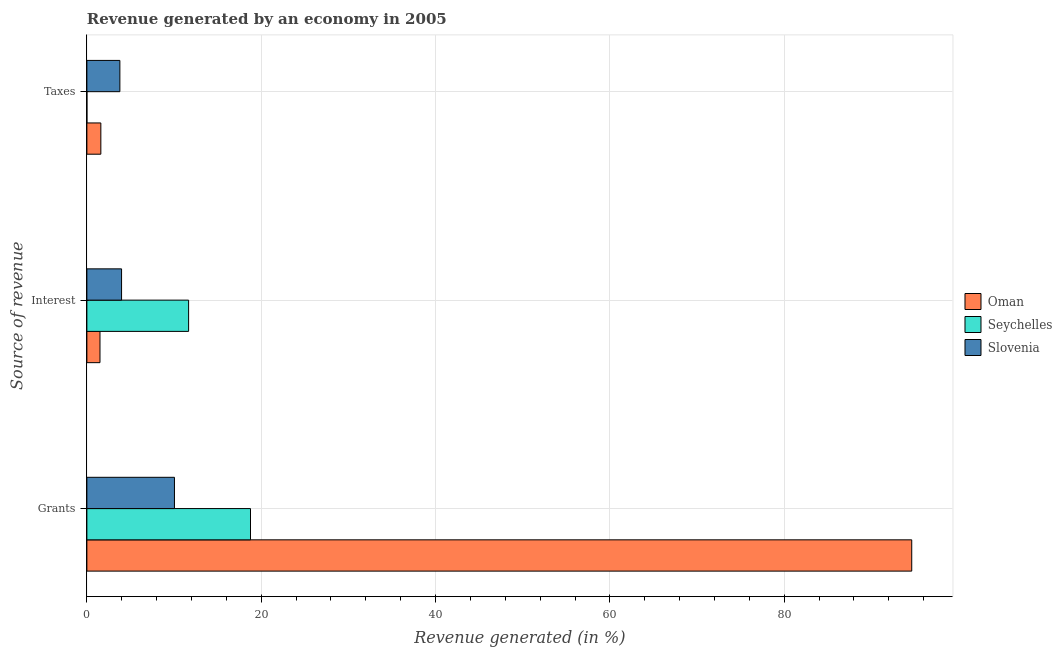How many bars are there on the 1st tick from the top?
Provide a succinct answer. 3. How many bars are there on the 2nd tick from the bottom?
Your response must be concise. 3. What is the label of the 1st group of bars from the top?
Offer a terse response. Taxes. What is the percentage of revenue generated by grants in Slovenia?
Your answer should be compact. 10.05. Across all countries, what is the maximum percentage of revenue generated by interest?
Your response must be concise. 11.67. Across all countries, what is the minimum percentage of revenue generated by taxes?
Provide a short and direct response. 0. In which country was the percentage of revenue generated by taxes maximum?
Your answer should be compact. Slovenia. In which country was the percentage of revenue generated by taxes minimum?
Provide a succinct answer. Seychelles. What is the total percentage of revenue generated by grants in the graph?
Provide a short and direct response. 123.44. What is the difference between the percentage of revenue generated by taxes in Slovenia and that in Oman?
Make the answer very short. 2.18. What is the difference between the percentage of revenue generated by taxes in Oman and the percentage of revenue generated by grants in Slovenia?
Offer a very short reply. -8.44. What is the average percentage of revenue generated by grants per country?
Offer a terse response. 41.15. What is the difference between the percentage of revenue generated by grants and percentage of revenue generated by taxes in Oman?
Give a very brief answer. 93.03. What is the ratio of the percentage of revenue generated by interest in Seychelles to that in Slovenia?
Make the answer very short. 2.93. Is the percentage of revenue generated by grants in Oman less than that in Slovenia?
Provide a short and direct response. No. What is the difference between the highest and the second highest percentage of revenue generated by taxes?
Your answer should be compact. 2.18. What is the difference between the highest and the lowest percentage of revenue generated by interest?
Keep it short and to the point. 10.17. Is the sum of the percentage of revenue generated by grants in Slovenia and Seychelles greater than the maximum percentage of revenue generated by interest across all countries?
Make the answer very short. Yes. What does the 3rd bar from the top in Interest represents?
Provide a short and direct response. Oman. What does the 3rd bar from the bottom in Grants represents?
Provide a succinct answer. Slovenia. Are all the bars in the graph horizontal?
Provide a short and direct response. Yes. How many countries are there in the graph?
Give a very brief answer. 3. What is the difference between two consecutive major ticks on the X-axis?
Your answer should be very brief. 20. Does the graph contain grids?
Make the answer very short. Yes. How are the legend labels stacked?
Your answer should be very brief. Vertical. What is the title of the graph?
Your response must be concise. Revenue generated by an economy in 2005. Does "Japan" appear as one of the legend labels in the graph?
Provide a succinct answer. No. What is the label or title of the X-axis?
Your answer should be very brief. Revenue generated (in %). What is the label or title of the Y-axis?
Your response must be concise. Source of revenue. What is the Revenue generated (in %) in Oman in Grants?
Make the answer very short. 94.63. What is the Revenue generated (in %) in Seychelles in Grants?
Offer a very short reply. 18.77. What is the Revenue generated (in %) of Slovenia in Grants?
Ensure brevity in your answer.  10.05. What is the Revenue generated (in %) in Oman in Interest?
Provide a succinct answer. 1.5. What is the Revenue generated (in %) of Seychelles in Interest?
Your response must be concise. 11.67. What is the Revenue generated (in %) in Slovenia in Interest?
Keep it short and to the point. 3.98. What is the Revenue generated (in %) in Oman in Taxes?
Provide a succinct answer. 1.6. What is the Revenue generated (in %) in Seychelles in Taxes?
Ensure brevity in your answer.  0. What is the Revenue generated (in %) of Slovenia in Taxes?
Provide a short and direct response. 3.79. Across all Source of revenue, what is the maximum Revenue generated (in %) of Oman?
Offer a very short reply. 94.63. Across all Source of revenue, what is the maximum Revenue generated (in %) of Seychelles?
Offer a terse response. 18.77. Across all Source of revenue, what is the maximum Revenue generated (in %) of Slovenia?
Offer a terse response. 10.05. Across all Source of revenue, what is the minimum Revenue generated (in %) of Oman?
Offer a very short reply. 1.5. Across all Source of revenue, what is the minimum Revenue generated (in %) of Seychelles?
Provide a short and direct response. 0. Across all Source of revenue, what is the minimum Revenue generated (in %) of Slovenia?
Make the answer very short. 3.79. What is the total Revenue generated (in %) of Oman in the graph?
Keep it short and to the point. 97.73. What is the total Revenue generated (in %) of Seychelles in the graph?
Provide a succinct answer. 30.44. What is the total Revenue generated (in %) in Slovenia in the graph?
Your answer should be compact. 17.81. What is the difference between the Revenue generated (in %) of Oman in Grants and that in Interest?
Your answer should be very brief. 93.13. What is the difference between the Revenue generated (in %) in Seychelles in Grants and that in Interest?
Your answer should be compact. 7.1. What is the difference between the Revenue generated (in %) in Slovenia in Grants and that in Interest?
Give a very brief answer. 6.07. What is the difference between the Revenue generated (in %) in Oman in Grants and that in Taxes?
Give a very brief answer. 93.03. What is the difference between the Revenue generated (in %) in Seychelles in Grants and that in Taxes?
Provide a short and direct response. 18.77. What is the difference between the Revenue generated (in %) in Slovenia in Grants and that in Taxes?
Your response must be concise. 6.26. What is the difference between the Revenue generated (in %) of Oman in Interest and that in Taxes?
Provide a succinct answer. -0.1. What is the difference between the Revenue generated (in %) of Seychelles in Interest and that in Taxes?
Your answer should be very brief. 11.67. What is the difference between the Revenue generated (in %) in Slovenia in Interest and that in Taxes?
Your answer should be very brief. 0.19. What is the difference between the Revenue generated (in %) in Oman in Grants and the Revenue generated (in %) in Seychelles in Interest?
Make the answer very short. 82.96. What is the difference between the Revenue generated (in %) in Oman in Grants and the Revenue generated (in %) in Slovenia in Interest?
Offer a terse response. 90.65. What is the difference between the Revenue generated (in %) of Seychelles in Grants and the Revenue generated (in %) of Slovenia in Interest?
Ensure brevity in your answer.  14.79. What is the difference between the Revenue generated (in %) of Oman in Grants and the Revenue generated (in %) of Seychelles in Taxes?
Provide a short and direct response. 94.63. What is the difference between the Revenue generated (in %) in Oman in Grants and the Revenue generated (in %) in Slovenia in Taxes?
Provide a succinct answer. 90.84. What is the difference between the Revenue generated (in %) in Seychelles in Grants and the Revenue generated (in %) in Slovenia in Taxes?
Provide a short and direct response. 14.98. What is the difference between the Revenue generated (in %) in Oman in Interest and the Revenue generated (in %) in Seychelles in Taxes?
Offer a very short reply. 1.5. What is the difference between the Revenue generated (in %) of Oman in Interest and the Revenue generated (in %) of Slovenia in Taxes?
Give a very brief answer. -2.28. What is the difference between the Revenue generated (in %) of Seychelles in Interest and the Revenue generated (in %) of Slovenia in Taxes?
Make the answer very short. 7.88. What is the average Revenue generated (in %) in Oman per Source of revenue?
Give a very brief answer. 32.58. What is the average Revenue generated (in %) in Seychelles per Source of revenue?
Your response must be concise. 10.15. What is the average Revenue generated (in %) of Slovenia per Source of revenue?
Provide a succinct answer. 5.94. What is the difference between the Revenue generated (in %) of Oman and Revenue generated (in %) of Seychelles in Grants?
Make the answer very short. 75.86. What is the difference between the Revenue generated (in %) in Oman and Revenue generated (in %) in Slovenia in Grants?
Keep it short and to the point. 84.58. What is the difference between the Revenue generated (in %) of Seychelles and Revenue generated (in %) of Slovenia in Grants?
Your response must be concise. 8.72. What is the difference between the Revenue generated (in %) of Oman and Revenue generated (in %) of Seychelles in Interest?
Offer a very short reply. -10.17. What is the difference between the Revenue generated (in %) in Oman and Revenue generated (in %) in Slovenia in Interest?
Your answer should be compact. -2.48. What is the difference between the Revenue generated (in %) of Seychelles and Revenue generated (in %) of Slovenia in Interest?
Ensure brevity in your answer.  7.69. What is the difference between the Revenue generated (in %) of Oman and Revenue generated (in %) of Seychelles in Taxes?
Make the answer very short. 1.6. What is the difference between the Revenue generated (in %) of Oman and Revenue generated (in %) of Slovenia in Taxes?
Your response must be concise. -2.18. What is the difference between the Revenue generated (in %) in Seychelles and Revenue generated (in %) in Slovenia in Taxes?
Give a very brief answer. -3.78. What is the ratio of the Revenue generated (in %) of Oman in Grants to that in Interest?
Your answer should be compact. 62.95. What is the ratio of the Revenue generated (in %) in Seychelles in Grants to that in Interest?
Offer a very short reply. 1.61. What is the ratio of the Revenue generated (in %) in Slovenia in Grants to that in Interest?
Offer a very short reply. 2.52. What is the ratio of the Revenue generated (in %) in Oman in Grants to that in Taxes?
Provide a succinct answer. 59.06. What is the ratio of the Revenue generated (in %) in Seychelles in Grants to that in Taxes?
Offer a very short reply. 1.71e+04. What is the ratio of the Revenue generated (in %) of Slovenia in Grants to that in Taxes?
Offer a very short reply. 2.65. What is the ratio of the Revenue generated (in %) in Oman in Interest to that in Taxes?
Your answer should be very brief. 0.94. What is the ratio of the Revenue generated (in %) of Seychelles in Interest to that in Taxes?
Provide a succinct answer. 1.06e+04. What is the ratio of the Revenue generated (in %) of Slovenia in Interest to that in Taxes?
Ensure brevity in your answer.  1.05. What is the difference between the highest and the second highest Revenue generated (in %) in Oman?
Provide a succinct answer. 93.03. What is the difference between the highest and the second highest Revenue generated (in %) in Seychelles?
Give a very brief answer. 7.1. What is the difference between the highest and the second highest Revenue generated (in %) in Slovenia?
Make the answer very short. 6.07. What is the difference between the highest and the lowest Revenue generated (in %) of Oman?
Ensure brevity in your answer.  93.13. What is the difference between the highest and the lowest Revenue generated (in %) of Seychelles?
Keep it short and to the point. 18.77. What is the difference between the highest and the lowest Revenue generated (in %) in Slovenia?
Provide a succinct answer. 6.26. 